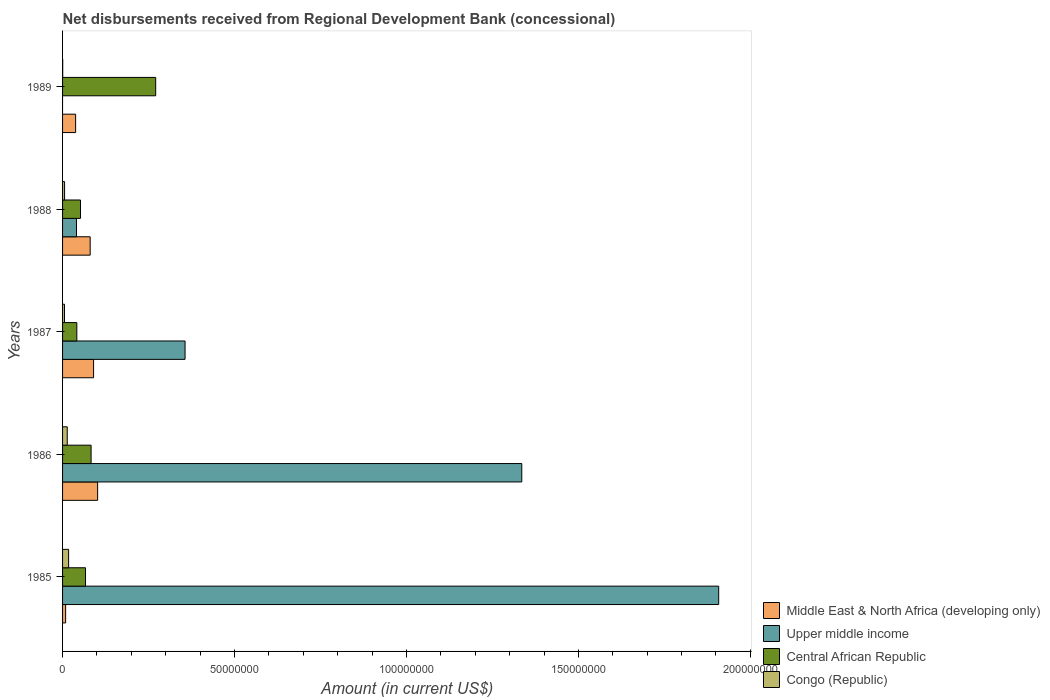Are the number of bars on each tick of the Y-axis equal?
Provide a succinct answer. No. How many bars are there on the 4th tick from the top?
Your response must be concise. 4. How many bars are there on the 1st tick from the bottom?
Ensure brevity in your answer.  4. In how many cases, is the number of bars for a given year not equal to the number of legend labels?
Offer a terse response. 1. What is the amount of disbursements received from Regional Development Bank in Congo (Republic) in 1987?
Make the answer very short. 5.61e+05. Across all years, what is the maximum amount of disbursements received from Regional Development Bank in Middle East & North Africa (developing only)?
Offer a terse response. 1.02e+07. Across all years, what is the minimum amount of disbursements received from Regional Development Bank in Central African Republic?
Offer a very short reply. 4.15e+06. In which year was the amount of disbursements received from Regional Development Bank in Upper middle income maximum?
Make the answer very short. 1985. What is the total amount of disbursements received from Regional Development Bank in Middle East & North Africa (developing only) in the graph?
Ensure brevity in your answer.  3.19e+07. What is the difference between the amount of disbursements received from Regional Development Bank in Central African Republic in 1986 and that in 1987?
Your response must be concise. 4.15e+06. What is the difference between the amount of disbursements received from Regional Development Bank in Middle East & North Africa (developing only) in 1988 and the amount of disbursements received from Regional Development Bank in Central African Republic in 1986?
Your response must be concise. -2.66e+05. What is the average amount of disbursements received from Regional Development Bank in Congo (Republic) per year?
Make the answer very short. 8.61e+05. In the year 1985, what is the difference between the amount of disbursements received from Regional Development Bank in Central African Republic and amount of disbursements received from Regional Development Bank in Upper middle income?
Your answer should be compact. -1.84e+08. In how many years, is the amount of disbursements received from Regional Development Bank in Central African Republic greater than 130000000 US$?
Ensure brevity in your answer.  0. What is the ratio of the amount of disbursements received from Regional Development Bank in Congo (Republic) in 1985 to that in 1986?
Make the answer very short. 1.29. Is the amount of disbursements received from Regional Development Bank in Congo (Republic) in 1985 less than that in 1986?
Ensure brevity in your answer.  No. Is the difference between the amount of disbursements received from Regional Development Bank in Central African Republic in 1985 and 1986 greater than the difference between the amount of disbursements received from Regional Development Bank in Upper middle income in 1985 and 1986?
Ensure brevity in your answer.  No. What is the difference between the highest and the second highest amount of disbursements received from Regional Development Bank in Central African Republic?
Your answer should be compact. 1.88e+07. What is the difference between the highest and the lowest amount of disbursements received from Regional Development Bank in Upper middle income?
Offer a very short reply. 1.91e+08. Is the sum of the amount of disbursements received from Regional Development Bank in Middle East & North Africa (developing only) in 1986 and 1988 greater than the maximum amount of disbursements received from Regional Development Bank in Upper middle income across all years?
Ensure brevity in your answer.  No. Is it the case that in every year, the sum of the amount of disbursements received from Regional Development Bank in Central African Republic and amount of disbursements received from Regional Development Bank in Upper middle income is greater than the sum of amount of disbursements received from Regional Development Bank in Middle East & North Africa (developing only) and amount of disbursements received from Regional Development Bank in Congo (Republic)?
Offer a terse response. No. Is it the case that in every year, the sum of the amount of disbursements received from Regional Development Bank in Central African Republic and amount of disbursements received from Regional Development Bank in Upper middle income is greater than the amount of disbursements received from Regional Development Bank in Congo (Republic)?
Offer a very short reply. Yes. How many years are there in the graph?
Give a very brief answer. 5. What is the difference between two consecutive major ticks on the X-axis?
Your answer should be very brief. 5.00e+07. Are the values on the major ticks of X-axis written in scientific E-notation?
Keep it short and to the point. No. Does the graph contain any zero values?
Make the answer very short. Yes. Does the graph contain grids?
Your answer should be compact. No. How many legend labels are there?
Offer a terse response. 4. How are the legend labels stacked?
Keep it short and to the point. Vertical. What is the title of the graph?
Your response must be concise. Net disbursements received from Regional Development Bank (concessional). Does "Luxembourg" appear as one of the legend labels in the graph?
Give a very brief answer. No. What is the label or title of the X-axis?
Give a very brief answer. Amount (in current US$). What is the Amount (in current US$) in Middle East & North Africa (developing only) in 1985?
Your answer should be very brief. 8.91e+05. What is the Amount (in current US$) in Upper middle income in 1985?
Your answer should be very brief. 1.91e+08. What is the Amount (in current US$) in Central African Republic in 1985?
Ensure brevity in your answer.  6.67e+06. What is the Amount (in current US$) in Congo (Republic) in 1985?
Your response must be concise. 1.76e+06. What is the Amount (in current US$) in Middle East & North Africa (developing only) in 1986?
Offer a very short reply. 1.02e+07. What is the Amount (in current US$) of Upper middle income in 1986?
Your answer should be compact. 1.34e+08. What is the Amount (in current US$) in Central African Republic in 1986?
Ensure brevity in your answer.  8.30e+06. What is the Amount (in current US$) of Congo (Republic) in 1986?
Keep it short and to the point. 1.36e+06. What is the Amount (in current US$) of Middle East & North Africa (developing only) in 1987?
Your answer should be very brief. 9.02e+06. What is the Amount (in current US$) in Upper middle income in 1987?
Give a very brief answer. 3.56e+07. What is the Amount (in current US$) in Central African Republic in 1987?
Make the answer very short. 4.15e+06. What is the Amount (in current US$) of Congo (Republic) in 1987?
Give a very brief answer. 5.61e+05. What is the Amount (in current US$) of Middle East & North Africa (developing only) in 1988?
Your response must be concise. 8.03e+06. What is the Amount (in current US$) in Upper middle income in 1988?
Ensure brevity in your answer.  4.05e+06. What is the Amount (in current US$) of Central African Republic in 1988?
Your response must be concise. 5.21e+06. What is the Amount (in current US$) of Congo (Republic) in 1988?
Your response must be concise. 5.84e+05. What is the Amount (in current US$) in Middle East & North Africa (developing only) in 1989?
Keep it short and to the point. 3.80e+06. What is the Amount (in current US$) in Central African Republic in 1989?
Make the answer very short. 2.71e+07. Across all years, what is the maximum Amount (in current US$) in Middle East & North Africa (developing only)?
Offer a very short reply. 1.02e+07. Across all years, what is the maximum Amount (in current US$) in Upper middle income?
Make the answer very short. 1.91e+08. Across all years, what is the maximum Amount (in current US$) of Central African Republic?
Your answer should be compact. 2.71e+07. Across all years, what is the maximum Amount (in current US$) in Congo (Republic)?
Give a very brief answer. 1.76e+06. Across all years, what is the minimum Amount (in current US$) in Middle East & North Africa (developing only)?
Provide a succinct answer. 8.91e+05. Across all years, what is the minimum Amount (in current US$) in Central African Republic?
Give a very brief answer. 4.15e+06. What is the total Amount (in current US$) in Middle East & North Africa (developing only) in the graph?
Your answer should be compact. 3.19e+07. What is the total Amount (in current US$) in Upper middle income in the graph?
Offer a very short reply. 3.64e+08. What is the total Amount (in current US$) of Central African Republic in the graph?
Your response must be concise. 5.14e+07. What is the total Amount (in current US$) of Congo (Republic) in the graph?
Your answer should be compact. 4.30e+06. What is the difference between the Amount (in current US$) of Middle East & North Africa (developing only) in 1985 and that in 1986?
Keep it short and to the point. -9.30e+06. What is the difference between the Amount (in current US$) in Upper middle income in 1985 and that in 1986?
Offer a terse response. 5.73e+07. What is the difference between the Amount (in current US$) in Central African Republic in 1985 and that in 1986?
Provide a succinct answer. -1.62e+06. What is the difference between the Amount (in current US$) of Congo (Republic) in 1985 and that in 1986?
Keep it short and to the point. 3.98e+05. What is the difference between the Amount (in current US$) of Middle East & North Africa (developing only) in 1985 and that in 1987?
Offer a terse response. -8.13e+06. What is the difference between the Amount (in current US$) of Upper middle income in 1985 and that in 1987?
Your response must be concise. 1.55e+08. What is the difference between the Amount (in current US$) in Central African Republic in 1985 and that in 1987?
Provide a short and direct response. 2.53e+06. What is the difference between the Amount (in current US$) in Congo (Republic) in 1985 and that in 1987?
Keep it short and to the point. 1.20e+06. What is the difference between the Amount (in current US$) in Middle East & North Africa (developing only) in 1985 and that in 1988?
Offer a terse response. -7.14e+06. What is the difference between the Amount (in current US$) of Upper middle income in 1985 and that in 1988?
Offer a very short reply. 1.87e+08. What is the difference between the Amount (in current US$) in Central African Republic in 1985 and that in 1988?
Provide a succinct answer. 1.47e+06. What is the difference between the Amount (in current US$) of Congo (Republic) in 1985 and that in 1988?
Your response must be concise. 1.17e+06. What is the difference between the Amount (in current US$) of Middle East & North Africa (developing only) in 1985 and that in 1989?
Provide a succinct answer. -2.91e+06. What is the difference between the Amount (in current US$) of Central African Republic in 1985 and that in 1989?
Your answer should be very brief. -2.04e+07. What is the difference between the Amount (in current US$) in Congo (Republic) in 1985 and that in 1989?
Ensure brevity in your answer.  1.72e+06. What is the difference between the Amount (in current US$) of Middle East & North Africa (developing only) in 1986 and that in 1987?
Provide a short and direct response. 1.17e+06. What is the difference between the Amount (in current US$) of Upper middle income in 1986 and that in 1987?
Offer a very short reply. 9.79e+07. What is the difference between the Amount (in current US$) in Central African Republic in 1986 and that in 1987?
Your answer should be very brief. 4.15e+06. What is the difference between the Amount (in current US$) in Congo (Republic) in 1986 and that in 1987?
Ensure brevity in your answer.  7.99e+05. What is the difference between the Amount (in current US$) in Middle East & North Africa (developing only) in 1986 and that in 1988?
Make the answer very short. 2.16e+06. What is the difference between the Amount (in current US$) in Upper middle income in 1986 and that in 1988?
Provide a short and direct response. 1.29e+08. What is the difference between the Amount (in current US$) in Central African Republic in 1986 and that in 1988?
Keep it short and to the point. 3.09e+06. What is the difference between the Amount (in current US$) in Congo (Republic) in 1986 and that in 1988?
Make the answer very short. 7.76e+05. What is the difference between the Amount (in current US$) in Middle East & North Africa (developing only) in 1986 and that in 1989?
Your answer should be very brief. 6.40e+06. What is the difference between the Amount (in current US$) in Central African Republic in 1986 and that in 1989?
Provide a short and direct response. -1.88e+07. What is the difference between the Amount (in current US$) in Congo (Republic) in 1986 and that in 1989?
Provide a succinct answer. 1.32e+06. What is the difference between the Amount (in current US$) of Middle East & North Africa (developing only) in 1987 and that in 1988?
Provide a short and direct response. 9.90e+05. What is the difference between the Amount (in current US$) in Upper middle income in 1987 and that in 1988?
Offer a terse response. 3.16e+07. What is the difference between the Amount (in current US$) in Central African Republic in 1987 and that in 1988?
Offer a terse response. -1.06e+06. What is the difference between the Amount (in current US$) in Congo (Republic) in 1987 and that in 1988?
Give a very brief answer. -2.30e+04. What is the difference between the Amount (in current US$) in Middle East & North Africa (developing only) in 1987 and that in 1989?
Give a very brief answer. 5.22e+06. What is the difference between the Amount (in current US$) of Central African Republic in 1987 and that in 1989?
Make the answer very short. -2.29e+07. What is the difference between the Amount (in current US$) in Congo (Republic) in 1987 and that in 1989?
Your answer should be compact. 5.21e+05. What is the difference between the Amount (in current US$) of Middle East & North Africa (developing only) in 1988 and that in 1989?
Your answer should be very brief. 4.23e+06. What is the difference between the Amount (in current US$) of Central African Republic in 1988 and that in 1989?
Your answer should be compact. -2.19e+07. What is the difference between the Amount (in current US$) of Congo (Republic) in 1988 and that in 1989?
Your answer should be very brief. 5.44e+05. What is the difference between the Amount (in current US$) of Middle East & North Africa (developing only) in 1985 and the Amount (in current US$) of Upper middle income in 1986?
Provide a succinct answer. -1.33e+08. What is the difference between the Amount (in current US$) of Middle East & North Africa (developing only) in 1985 and the Amount (in current US$) of Central African Republic in 1986?
Your answer should be compact. -7.40e+06. What is the difference between the Amount (in current US$) in Middle East & North Africa (developing only) in 1985 and the Amount (in current US$) in Congo (Republic) in 1986?
Offer a very short reply. -4.69e+05. What is the difference between the Amount (in current US$) in Upper middle income in 1985 and the Amount (in current US$) in Central African Republic in 1986?
Provide a short and direct response. 1.82e+08. What is the difference between the Amount (in current US$) in Upper middle income in 1985 and the Amount (in current US$) in Congo (Republic) in 1986?
Make the answer very short. 1.89e+08. What is the difference between the Amount (in current US$) of Central African Republic in 1985 and the Amount (in current US$) of Congo (Republic) in 1986?
Make the answer very short. 5.31e+06. What is the difference between the Amount (in current US$) of Middle East & North Africa (developing only) in 1985 and the Amount (in current US$) of Upper middle income in 1987?
Your answer should be compact. -3.47e+07. What is the difference between the Amount (in current US$) of Middle East & North Africa (developing only) in 1985 and the Amount (in current US$) of Central African Republic in 1987?
Offer a terse response. -3.26e+06. What is the difference between the Amount (in current US$) of Middle East & North Africa (developing only) in 1985 and the Amount (in current US$) of Congo (Republic) in 1987?
Provide a succinct answer. 3.30e+05. What is the difference between the Amount (in current US$) in Upper middle income in 1985 and the Amount (in current US$) in Central African Republic in 1987?
Your answer should be very brief. 1.87e+08. What is the difference between the Amount (in current US$) of Upper middle income in 1985 and the Amount (in current US$) of Congo (Republic) in 1987?
Offer a very short reply. 1.90e+08. What is the difference between the Amount (in current US$) in Central African Republic in 1985 and the Amount (in current US$) in Congo (Republic) in 1987?
Offer a terse response. 6.11e+06. What is the difference between the Amount (in current US$) in Middle East & North Africa (developing only) in 1985 and the Amount (in current US$) in Upper middle income in 1988?
Your answer should be very brief. -3.16e+06. What is the difference between the Amount (in current US$) in Middle East & North Africa (developing only) in 1985 and the Amount (in current US$) in Central African Republic in 1988?
Ensure brevity in your answer.  -4.32e+06. What is the difference between the Amount (in current US$) of Middle East & North Africa (developing only) in 1985 and the Amount (in current US$) of Congo (Republic) in 1988?
Offer a very short reply. 3.07e+05. What is the difference between the Amount (in current US$) in Upper middle income in 1985 and the Amount (in current US$) in Central African Republic in 1988?
Provide a succinct answer. 1.86e+08. What is the difference between the Amount (in current US$) of Upper middle income in 1985 and the Amount (in current US$) of Congo (Republic) in 1988?
Make the answer very short. 1.90e+08. What is the difference between the Amount (in current US$) in Central African Republic in 1985 and the Amount (in current US$) in Congo (Republic) in 1988?
Provide a short and direct response. 6.09e+06. What is the difference between the Amount (in current US$) in Middle East & North Africa (developing only) in 1985 and the Amount (in current US$) in Central African Republic in 1989?
Make the answer very short. -2.62e+07. What is the difference between the Amount (in current US$) in Middle East & North Africa (developing only) in 1985 and the Amount (in current US$) in Congo (Republic) in 1989?
Give a very brief answer. 8.51e+05. What is the difference between the Amount (in current US$) of Upper middle income in 1985 and the Amount (in current US$) of Central African Republic in 1989?
Your answer should be compact. 1.64e+08. What is the difference between the Amount (in current US$) of Upper middle income in 1985 and the Amount (in current US$) of Congo (Republic) in 1989?
Offer a terse response. 1.91e+08. What is the difference between the Amount (in current US$) of Central African Republic in 1985 and the Amount (in current US$) of Congo (Republic) in 1989?
Your answer should be compact. 6.63e+06. What is the difference between the Amount (in current US$) in Middle East & North Africa (developing only) in 1986 and the Amount (in current US$) in Upper middle income in 1987?
Offer a terse response. -2.54e+07. What is the difference between the Amount (in current US$) of Middle East & North Africa (developing only) in 1986 and the Amount (in current US$) of Central African Republic in 1987?
Make the answer very short. 6.05e+06. What is the difference between the Amount (in current US$) in Middle East & North Africa (developing only) in 1986 and the Amount (in current US$) in Congo (Republic) in 1987?
Provide a succinct answer. 9.63e+06. What is the difference between the Amount (in current US$) in Upper middle income in 1986 and the Amount (in current US$) in Central African Republic in 1987?
Your response must be concise. 1.29e+08. What is the difference between the Amount (in current US$) in Upper middle income in 1986 and the Amount (in current US$) in Congo (Republic) in 1987?
Provide a succinct answer. 1.33e+08. What is the difference between the Amount (in current US$) in Central African Republic in 1986 and the Amount (in current US$) in Congo (Republic) in 1987?
Provide a short and direct response. 7.73e+06. What is the difference between the Amount (in current US$) of Middle East & North Africa (developing only) in 1986 and the Amount (in current US$) of Upper middle income in 1988?
Your answer should be very brief. 6.14e+06. What is the difference between the Amount (in current US$) in Middle East & North Africa (developing only) in 1986 and the Amount (in current US$) in Central African Republic in 1988?
Offer a terse response. 4.98e+06. What is the difference between the Amount (in current US$) in Middle East & North Africa (developing only) in 1986 and the Amount (in current US$) in Congo (Republic) in 1988?
Offer a very short reply. 9.61e+06. What is the difference between the Amount (in current US$) in Upper middle income in 1986 and the Amount (in current US$) in Central African Republic in 1988?
Your answer should be compact. 1.28e+08. What is the difference between the Amount (in current US$) of Upper middle income in 1986 and the Amount (in current US$) of Congo (Republic) in 1988?
Ensure brevity in your answer.  1.33e+08. What is the difference between the Amount (in current US$) in Central African Republic in 1986 and the Amount (in current US$) in Congo (Republic) in 1988?
Your answer should be compact. 7.71e+06. What is the difference between the Amount (in current US$) of Middle East & North Africa (developing only) in 1986 and the Amount (in current US$) of Central African Republic in 1989?
Provide a succinct answer. -1.69e+07. What is the difference between the Amount (in current US$) in Middle East & North Africa (developing only) in 1986 and the Amount (in current US$) in Congo (Republic) in 1989?
Your answer should be very brief. 1.02e+07. What is the difference between the Amount (in current US$) in Upper middle income in 1986 and the Amount (in current US$) in Central African Republic in 1989?
Provide a succinct answer. 1.06e+08. What is the difference between the Amount (in current US$) in Upper middle income in 1986 and the Amount (in current US$) in Congo (Republic) in 1989?
Provide a short and direct response. 1.33e+08. What is the difference between the Amount (in current US$) in Central African Republic in 1986 and the Amount (in current US$) in Congo (Republic) in 1989?
Give a very brief answer. 8.26e+06. What is the difference between the Amount (in current US$) in Middle East & North Africa (developing only) in 1987 and the Amount (in current US$) in Upper middle income in 1988?
Provide a succinct answer. 4.97e+06. What is the difference between the Amount (in current US$) in Middle East & North Africa (developing only) in 1987 and the Amount (in current US$) in Central African Republic in 1988?
Make the answer very short. 3.81e+06. What is the difference between the Amount (in current US$) in Middle East & North Africa (developing only) in 1987 and the Amount (in current US$) in Congo (Republic) in 1988?
Your answer should be compact. 8.44e+06. What is the difference between the Amount (in current US$) in Upper middle income in 1987 and the Amount (in current US$) in Central African Republic in 1988?
Your answer should be compact. 3.04e+07. What is the difference between the Amount (in current US$) of Upper middle income in 1987 and the Amount (in current US$) of Congo (Republic) in 1988?
Offer a terse response. 3.50e+07. What is the difference between the Amount (in current US$) in Central African Republic in 1987 and the Amount (in current US$) in Congo (Republic) in 1988?
Offer a very short reply. 3.56e+06. What is the difference between the Amount (in current US$) of Middle East & North Africa (developing only) in 1987 and the Amount (in current US$) of Central African Republic in 1989?
Your answer should be compact. -1.81e+07. What is the difference between the Amount (in current US$) in Middle East & North Africa (developing only) in 1987 and the Amount (in current US$) in Congo (Republic) in 1989?
Give a very brief answer. 8.98e+06. What is the difference between the Amount (in current US$) of Upper middle income in 1987 and the Amount (in current US$) of Central African Republic in 1989?
Offer a very short reply. 8.54e+06. What is the difference between the Amount (in current US$) of Upper middle income in 1987 and the Amount (in current US$) of Congo (Republic) in 1989?
Ensure brevity in your answer.  3.56e+07. What is the difference between the Amount (in current US$) in Central African Republic in 1987 and the Amount (in current US$) in Congo (Republic) in 1989?
Keep it short and to the point. 4.11e+06. What is the difference between the Amount (in current US$) in Middle East & North Africa (developing only) in 1988 and the Amount (in current US$) in Central African Republic in 1989?
Make the answer very short. -1.90e+07. What is the difference between the Amount (in current US$) in Middle East & North Africa (developing only) in 1988 and the Amount (in current US$) in Congo (Republic) in 1989?
Your answer should be compact. 7.99e+06. What is the difference between the Amount (in current US$) in Upper middle income in 1988 and the Amount (in current US$) in Central African Republic in 1989?
Offer a very short reply. -2.30e+07. What is the difference between the Amount (in current US$) of Upper middle income in 1988 and the Amount (in current US$) of Congo (Republic) in 1989?
Your response must be concise. 4.01e+06. What is the difference between the Amount (in current US$) of Central African Republic in 1988 and the Amount (in current US$) of Congo (Republic) in 1989?
Give a very brief answer. 5.17e+06. What is the average Amount (in current US$) of Middle East & North Africa (developing only) per year?
Provide a short and direct response. 6.39e+06. What is the average Amount (in current US$) of Upper middle income per year?
Provide a succinct answer. 7.28e+07. What is the average Amount (in current US$) of Central African Republic per year?
Offer a very short reply. 1.03e+07. What is the average Amount (in current US$) of Congo (Republic) per year?
Give a very brief answer. 8.61e+05. In the year 1985, what is the difference between the Amount (in current US$) of Middle East & North Africa (developing only) and Amount (in current US$) of Upper middle income?
Ensure brevity in your answer.  -1.90e+08. In the year 1985, what is the difference between the Amount (in current US$) in Middle East & North Africa (developing only) and Amount (in current US$) in Central African Republic?
Make the answer very short. -5.78e+06. In the year 1985, what is the difference between the Amount (in current US$) of Middle East & North Africa (developing only) and Amount (in current US$) of Congo (Republic)?
Ensure brevity in your answer.  -8.67e+05. In the year 1985, what is the difference between the Amount (in current US$) in Upper middle income and Amount (in current US$) in Central African Republic?
Give a very brief answer. 1.84e+08. In the year 1985, what is the difference between the Amount (in current US$) in Upper middle income and Amount (in current US$) in Congo (Republic)?
Keep it short and to the point. 1.89e+08. In the year 1985, what is the difference between the Amount (in current US$) in Central African Republic and Amount (in current US$) in Congo (Republic)?
Provide a short and direct response. 4.92e+06. In the year 1986, what is the difference between the Amount (in current US$) in Middle East & North Africa (developing only) and Amount (in current US$) in Upper middle income?
Your answer should be very brief. -1.23e+08. In the year 1986, what is the difference between the Amount (in current US$) in Middle East & North Africa (developing only) and Amount (in current US$) in Central African Republic?
Give a very brief answer. 1.90e+06. In the year 1986, what is the difference between the Amount (in current US$) of Middle East & North Africa (developing only) and Amount (in current US$) of Congo (Republic)?
Offer a terse response. 8.83e+06. In the year 1986, what is the difference between the Amount (in current US$) in Upper middle income and Amount (in current US$) in Central African Republic?
Make the answer very short. 1.25e+08. In the year 1986, what is the difference between the Amount (in current US$) of Upper middle income and Amount (in current US$) of Congo (Republic)?
Offer a very short reply. 1.32e+08. In the year 1986, what is the difference between the Amount (in current US$) in Central African Republic and Amount (in current US$) in Congo (Republic)?
Offer a terse response. 6.94e+06. In the year 1987, what is the difference between the Amount (in current US$) in Middle East & North Africa (developing only) and Amount (in current US$) in Upper middle income?
Give a very brief answer. -2.66e+07. In the year 1987, what is the difference between the Amount (in current US$) in Middle East & North Africa (developing only) and Amount (in current US$) in Central African Republic?
Give a very brief answer. 4.87e+06. In the year 1987, what is the difference between the Amount (in current US$) of Middle East & North Africa (developing only) and Amount (in current US$) of Congo (Republic)?
Provide a succinct answer. 8.46e+06. In the year 1987, what is the difference between the Amount (in current US$) in Upper middle income and Amount (in current US$) in Central African Republic?
Your response must be concise. 3.15e+07. In the year 1987, what is the difference between the Amount (in current US$) in Upper middle income and Amount (in current US$) in Congo (Republic)?
Ensure brevity in your answer.  3.51e+07. In the year 1987, what is the difference between the Amount (in current US$) of Central African Republic and Amount (in current US$) of Congo (Republic)?
Keep it short and to the point. 3.58e+06. In the year 1988, what is the difference between the Amount (in current US$) of Middle East & North Africa (developing only) and Amount (in current US$) of Upper middle income?
Provide a short and direct response. 3.98e+06. In the year 1988, what is the difference between the Amount (in current US$) of Middle East & North Africa (developing only) and Amount (in current US$) of Central African Republic?
Your response must be concise. 2.82e+06. In the year 1988, what is the difference between the Amount (in current US$) of Middle East & North Africa (developing only) and Amount (in current US$) of Congo (Republic)?
Make the answer very short. 7.44e+06. In the year 1988, what is the difference between the Amount (in current US$) in Upper middle income and Amount (in current US$) in Central African Republic?
Provide a short and direct response. -1.16e+06. In the year 1988, what is the difference between the Amount (in current US$) in Upper middle income and Amount (in current US$) in Congo (Republic)?
Keep it short and to the point. 3.47e+06. In the year 1988, what is the difference between the Amount (in current US$) in Central African Republic and Amount (in current US$) in Congo (Republic)?
Your answer should be very brief. 4.62e+06. In the year 1989, what is the difference between the Amount (in current US$) in Middle East & North Africa (developing only) and Amount (in current US$) in Central African Republic?
Keep it short and to the point. -2.33e+07. In the year 1989, what is the difference between the Amount (in current US$) in Middle East & North Africa (developing only) and Amount (in current US$) in Congo (Republic)?
Keep it short and to the point. 3.76e+06. In the year 1989, what is the difference between the Amount (in current US$) of Central African Republic and Amount (in current US$) of Congo (Republic)?
Offer a very short reply. 2.70e+07. What is the ratio of the Amount (in current US$) in Middle East & North Africa (developing only) in 1985 to that in 1986?
Provide a short and direct response. 0.09. What is the ratio of the Amount (in current US$) in Upper middle income in 1985 to that in 1986?
Ensure brevity in your answer.  1.43. What is the ratio of the Amount (in current US$) of Central African Republic in 1985 to that in 1986?
Ensure brevity in your answer.  0.8. What is the ratio of the Amount (in current US$) of Congo (Republic) in 1985 to that in 1986?
Ensure brevity in your answer.  1.29. What is the ratio of the Amount (in current US$) of Middle East & North Africa (developing only) in 1985 to that in 1987?
Provide a short and direct response. 0.1. What is the ratio of the Amount (in current US$) of Upper middle income in 1985 to that in 1987?
Give a very brief answer. 5.36. What is the ratio of the Amount (in current US$) of Central African Republic in 1985 to that in 1987?
Your response must be concise. 1.61. What is the ratio of the Amount (in current US$) of Congo (Republic) in 1985 to that in 1987?
Provide a succinct answer. 3.13. What is the ratio of the Amount (in current US$) of Middle East & North Africa (developing only) in 1985 to that in 1988?
Offer a very short reply. 0.11. What is the ratio of the Amount (in current US$) of Upper middle income in 1985 to that in 1988?
Your answer should be compact. 47.07. What is the ratio of the Amount (in current US$) of Central African Republic in 1985 to that in 1988?
Offer a very short reply. 1.28. What is the ratio of the Amount (in current US$) in Congo (Republic) in 1985 to that in 1988?
Ensure brevity in your answer.  3.01. What is the ratio of the Amount (in current US$) in Middle East & North Africa (developing only) in 1985 to that in 1989?
Ensure brevity in your answer.  0.23. What is the ratio of the Amount (in current US$) in Central African Republic in 1985 to that in 1989?
Your response must be concise. 0.25. What is the ratio of the Amount (in current US$) in Congo (Republic) in 1985 to that in 1989?
Provide a succinct answer. 43.95. What is the ratio of the Amount (in current US$) of Middle East & North Africa (developing only) in 1986 to that in 1987?
Provide a short and direct response. 1.13. What is the ratio of the Amount (in current US$) of Upper middle income in 1986 to that in 1987?
Make the answer very short. 3.75. What is the ratio of the Amount (in current US$) of Central African Republic in 1986 to that in 1987?
Keep it short and to the point. 2. What is the ratio of the Amount (in current US$) in Congo (Republic) in 1986 to that in 1987?
Your answer should be compact. 2.42. What is the ratio of the Amount (in current US$) of Middle East & North Africa (developing only) in 1986 to that in 1988?
Provide a short and direct response. 1.27. What is the ratio of the Amount (in current US$) of Upper middle income in 1986 to that in 1988?
Your answer should be very brief. 32.95. What is the ratio of the Amount (in current US$) of Central African Republic in 1986 to that in 1988?
Your answer should be very brief. 1.59. What is the ratio of the Amount (in current US$) in Congo (Republic) in 1986 to that in 1988?
Give a very brief answer. 2.33. What is the ratio of the Amount (in current US$) of Middle East & North Africa (developing only) in 1986 to that in 1989?
Make the answer very short. 2.68. What is the ratio of the Amount (in current US$) in Central African Republic in 1986 to that in 1989?
Keep it short and to the point. 0.31. What is the ratio of the Amount (in current US$) of Congo (Republic) in 1986 to that in 1989?
Keep it short and to the point. 34. What is the ratio of the Amount (in current US$) in Middle East & North Africa (developing only) in 1987 to that in 1988?
Your response must be concise. 1.12. What is the ratio of the Amount (in current US$) in Upper middle income in 1987 to that in 1988?
Your response must be concise. 8.79. What is the ratio of the Amount (in current US$) in Central African Republic in 1987 to that in 1988?
Offer a very short reply. 0.8. What is the ratio of the Amount (in current US$) in Congo (Republic) in 1987 to that in 1988?
Give a very brief answer. 0.96. What is the ratio of the Amount (in current US$) in Middle East & North Africa (developing only) in 1987 to that in 1989?
Provide a short and direct response. 2.38. What is the ratio of the Amount (in current US$) in Central African Republic in 1987 to that in 1989?
Provide a succinct answer. 0.15. What is the ratio of the Amount (in current US$) of Congo (Republic) in 1987 to that in 1989?
Keep it short and to the point. 14.03. What is the ratio of the Amount (in current US$) of Middle East & North Africa (developing only) in 1988 to that in 1989?
Provide a short and direct response. 2.11. What is the ratio of the Amount (in current US$) in Central African Republic in 1988 to that in 1989?
Give a very brief answer. 0.19. What is the difference between the highest and the second highest Amount (in current US$) of Middle East & North Africa (developing only)?
Your response must be concise. 1.17e+06. What is the difference between the highest and the second highest Amount (in current US$) in Upper middle income?
Provide a succinct answer. 5.73e+07. What is the difference between the highest and the second highest Amount (in current US$) of Central African Republic?
Your answer should be compact. 1.88e+07. What is the difference between the highest and the second highest Amount (in current US$) of Congo (Republic)?
Give a very brief answer. 3.98e+05. What is the difference between the highest and the lowest Amount (in current US$) in Middle East & North Africa (developing only)?
Offer a terse response. 9.30e+06. What is the difference between the highest and the lowest Amount (in current US$) in Upper middle income?
Your answer should be very brief. 1.91e+08. What is the difference between the highest and the lowest Amount (in current US$) of Central African Republic?
Give a very brief answer. 2.29e+07. What is the difference between the highest and the lowest Amount (in current US$) of Congo (Republic)?
Offer a very short reply. 1.72e+06. 